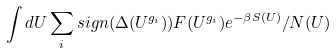<formula> <loc_0><loc_0><loc_500><loc_500>\int d U \sum _ { i } s i g n ( \Delta ( U ^ { g _ { i } } ) ) F ( U ^ { g _ { i } } ) e ^ { - \beta S ( U ) } / N ( U )</formula> 